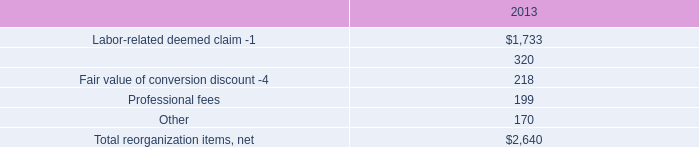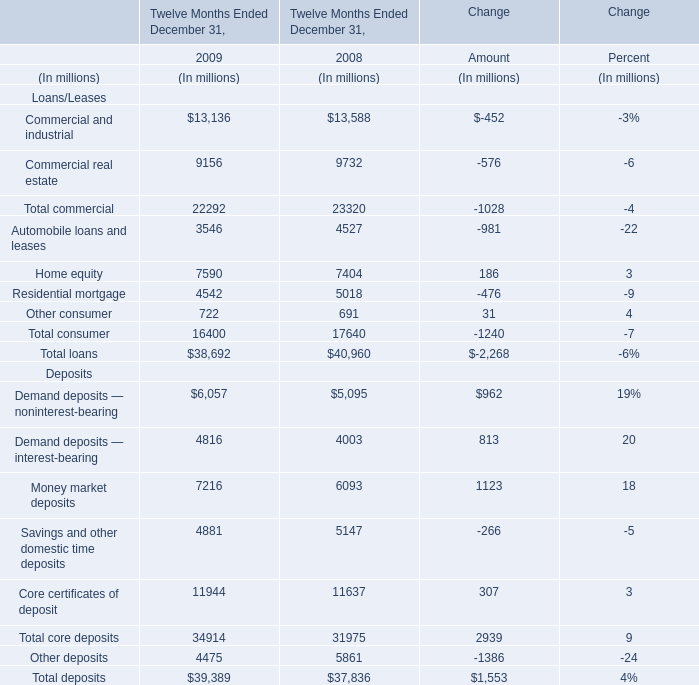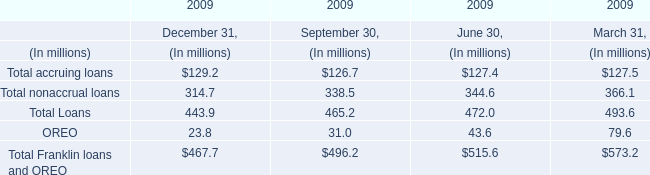What was the sum of Loans/Leases without those Loans/Leases greater than 4000, in 2009? (in million) 
Computations: (3546 + 722)
Answer: 4268.0. 